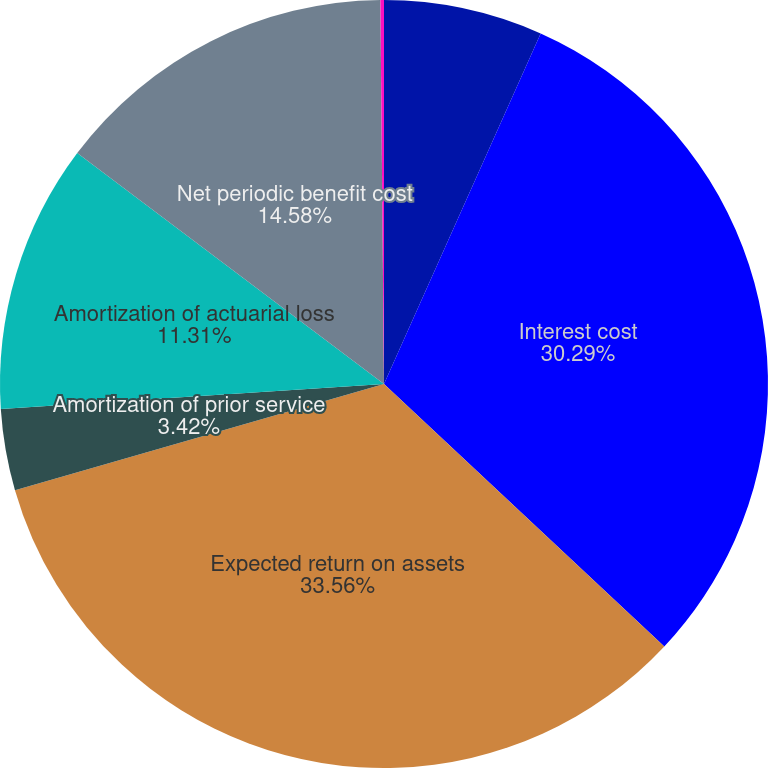Convert chart. <chart><loc_0><loc_0><loc_500><loc_500><pie_chart><fcel>Service cost<fcel>Interest cost<fcel>Expected return on assets<fcel>Amortization of prior service<fcel>Amortization of actuarial loss<fcel>Net periodic benefit cost<fcel>Amortization of actuarial<nl><fcel>6.69%<fcel>30.29%<fcel>33.57%<fcel>3.42%<fcel>11.31%<fcel>14.58%<fcel>0.15%<nl></chart> 